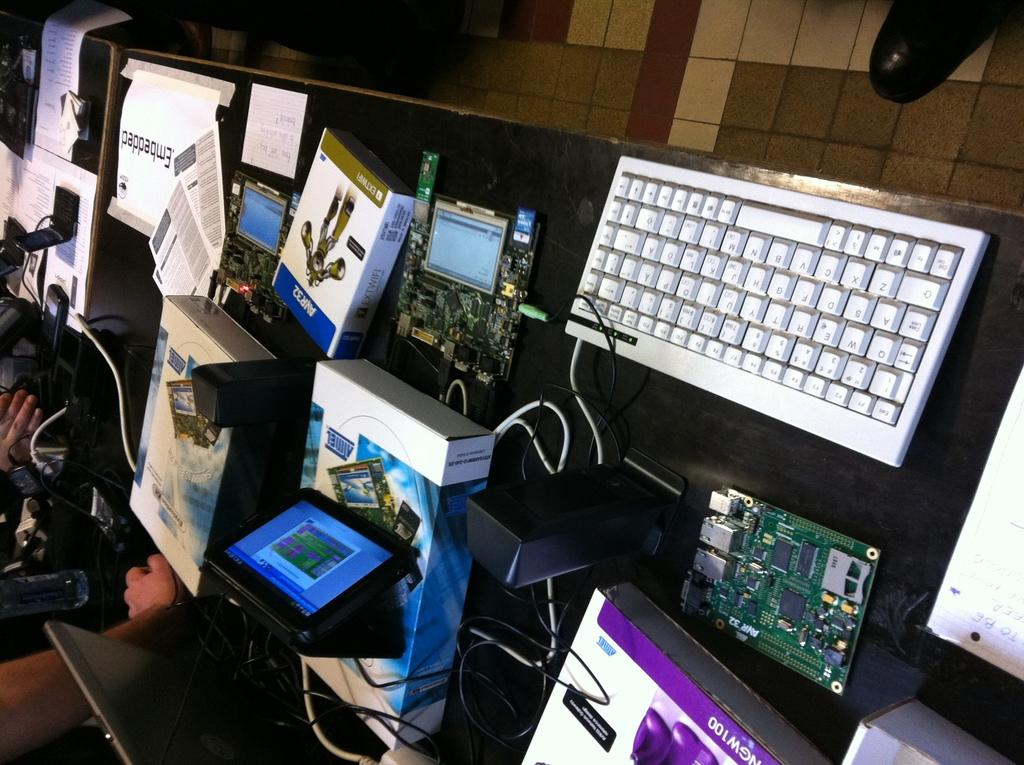<image>
Write a terse but informative summary of the picture. Computer parts on a table with one part named "AVR32". 